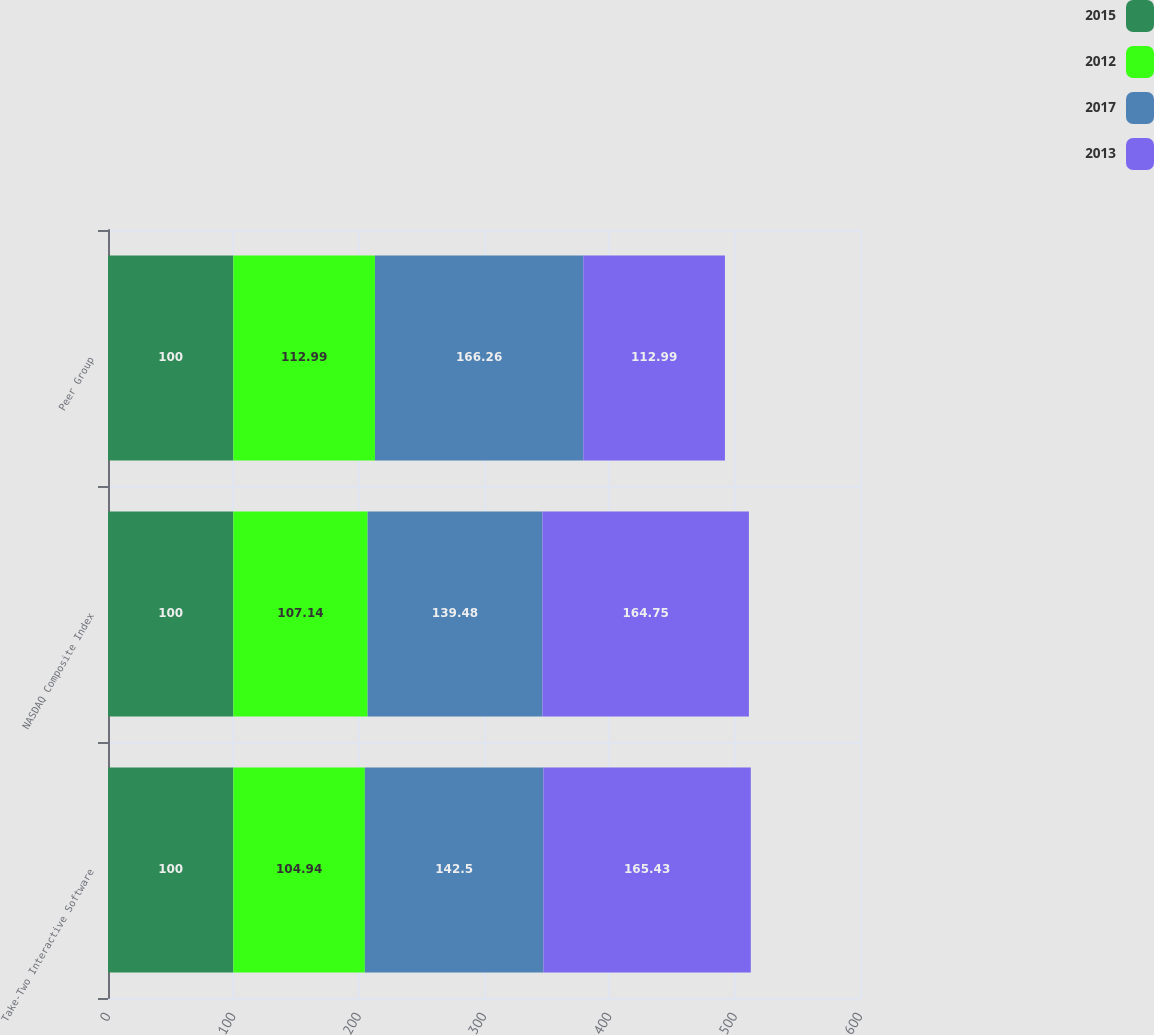<chart> <loc_0><loc_0><loc_500><loc_500><stacked_bar_chart><ecel><fcel>Take-Two Interactive Software<fcel>NASDAQ Composite Index<fcel>Peer Group<nl><fcel>2015<fcel>100<fcel>100<fcel>100<nl><fcel>2012<fcel>104.94<fcel>107.14<fcel>112.99<nl><fcel>2017<fcel>142.5<fcel>139.48<fcel>166.26<nl><fcel>2013<fcel>165.43<fcel>164.75<fcel>112.99<nl></chart> 